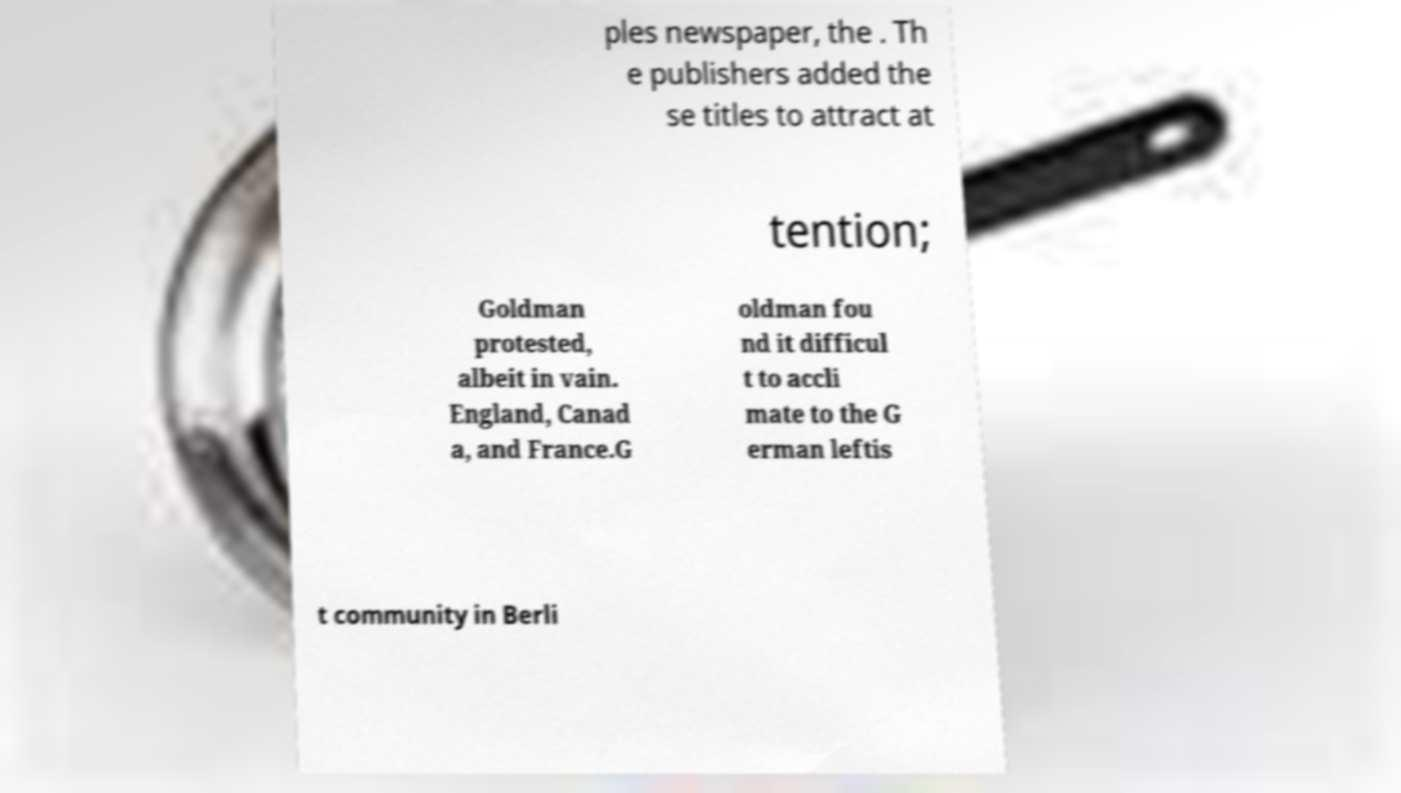What messages or text are displayed in this image? I need them in a readable, typed format. ples newspaper, the . Th e publishers added the se titles to attract at tention; Goldman protested, albeit in vain. England, Canad a, and France.G oldman fou nd it difficul t to accli mate to the G erman leftis t community in Berli 